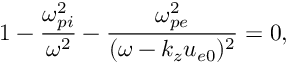<formula> <loc_0><loc_0><loc_500><loc_500>1 - \frac { \omega _ { p i } ^ { 2 } } { \omega ^ { 2 } } - \frac { \omega _ { p e } ^ { 2 } } { ( \omega - k _ { z } u _ { e 0 } ) ^ { 2 } } = 0 ,</formula> 